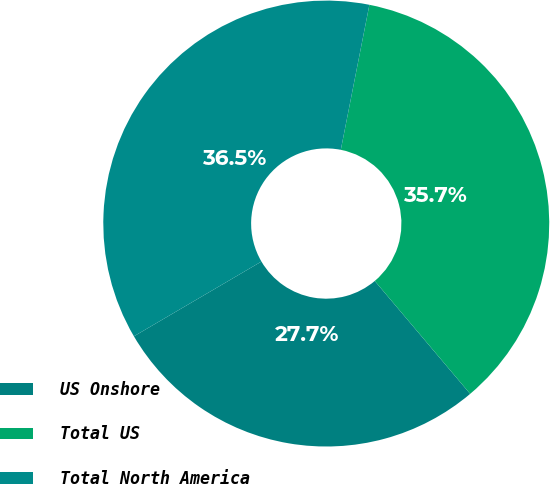Convert chart to OTSL. <chart><loc_0><loc_0><loc_500><loc_500><pie_chart><fcel>US Onshore<fcel>Total US<fcel>Total North America<nl><fcel>27.73%<fcel>35.74%<fcel>36.54%<nl></chart> 